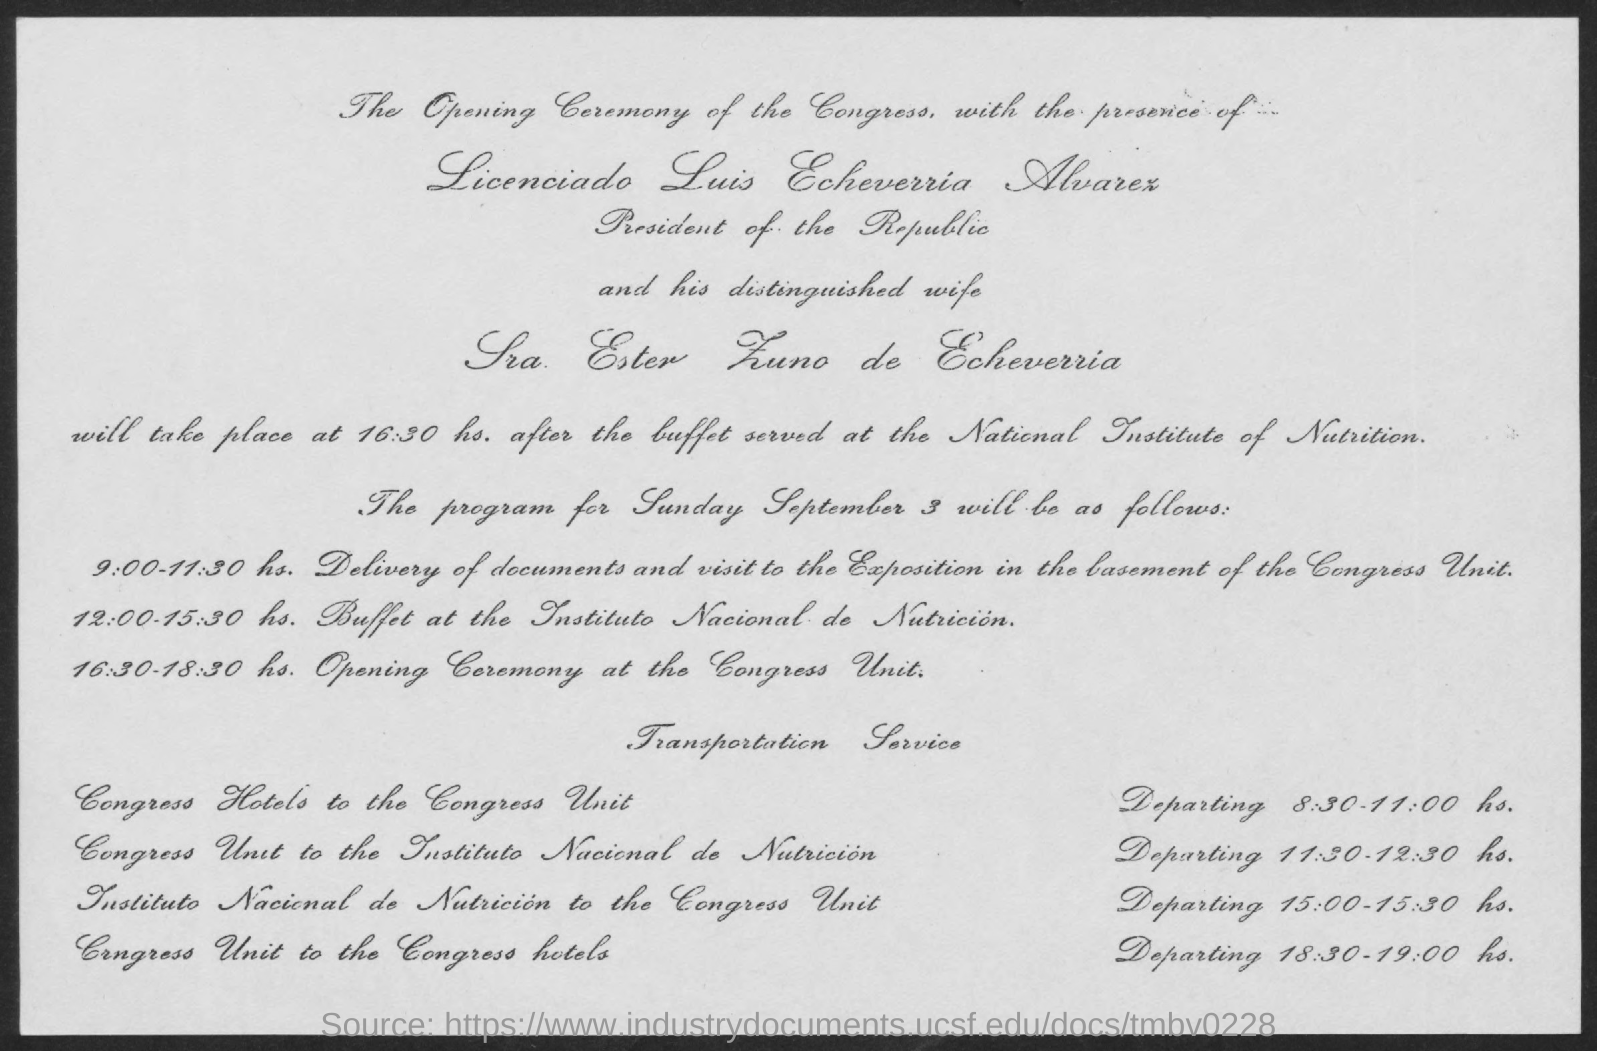Who is the President of the Republic?
Your answer should be very brief. Licenciado Luis Echeverria Alvarex. 